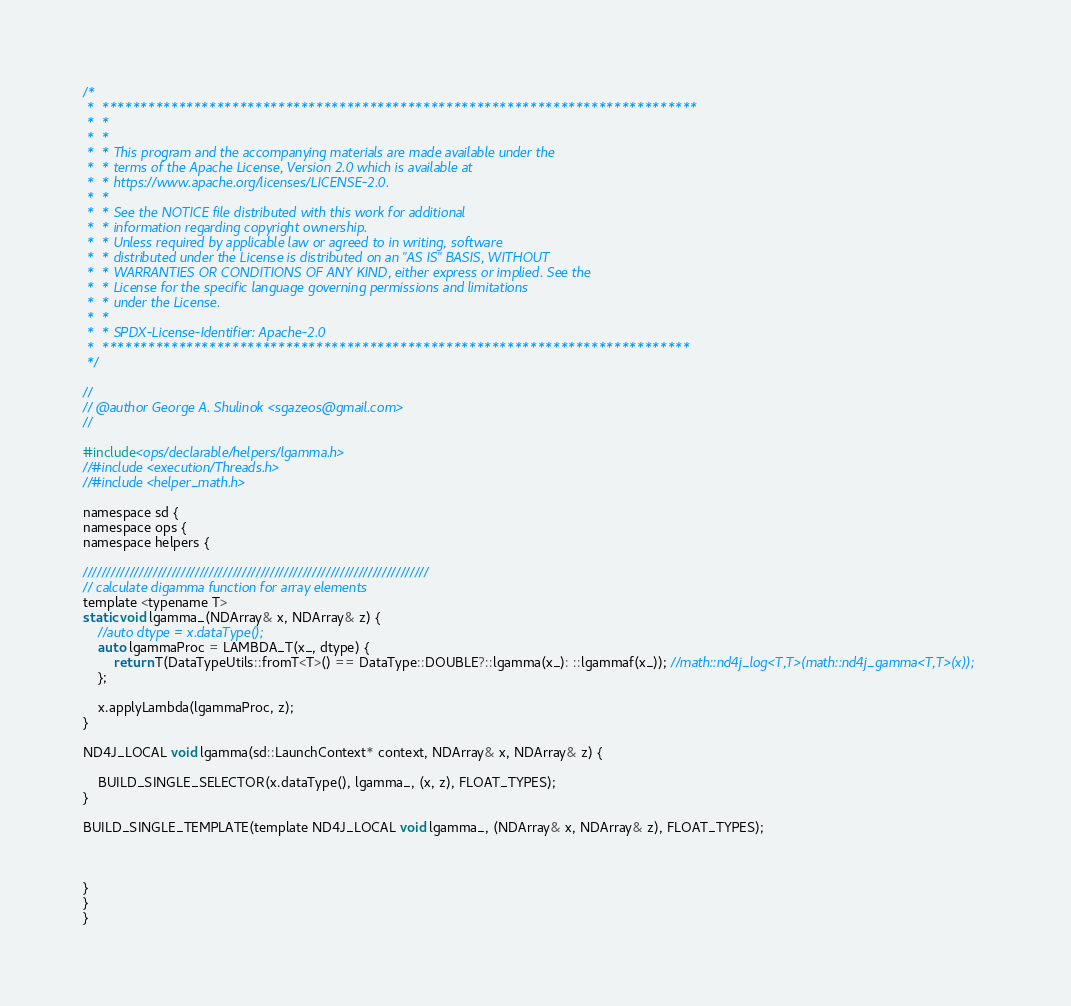Convert code to text. <code><loc_0><loc_0><loc_500><loc_500><_Cuda_>/*
 *  ******************************************************************************
 *  *
 *  *
 *  * This program and the accompanying materials are made available under the
 *  * terms of the Apache License, Version 2.0 which is available at
 *  * https://www.apache.org/licenses/LICENSE-2.0.
 *  *
 *  * See the NOTICE file distributed with this work for additional
 *  * information regarding copyright ownership.
 *  * Unless required by applicable law or agreed to in writing, software
 *  * distributed under the License is distributed on an "AS IS" BASIS, WITHOUT
 *  * WARRANTIES OR CONDITIONS OF ANY KIND, either express or implied. See the
 *  * License for the specific language governing permissions and limitations
 *  * under the License.
 *  *
 *  * SPDX-License-Identifier: Apache-2.0
 *  *****************************************************************************
 */

//
// @author George A. Shulinok <sgazeos@gmail.com>
//

#include<ops/declarable/helpers/lgamma.h>
//#include <execution/Threads.h>
//#include <helper_math.h>

namespace sd {
namespace ops {
namespace helpers {

//////////////////////////////////////////////////////////////////////////
// calculate digamma function for array elements
template <typename T>
static void lgamma_(NDArray& x, NDArray& z) {
    //auto dtype = x.dataType();
    auto lgammaProc = LAMBDA_T(x_, dtype) {
        return T(DataTypeUtils::fromT<T>() == DataType::DOUBLE?::lgamma(x_): ::lgammaf(x_)); //math::nd4j_log<T,T>(math::nd4j_gamma<T,T>(x));
    };

    x.applyLambda(lgammaProc, z);
}

ND4J_LOCAL void lgamma(sd::LaunchContext* context, NDArray& x, NDArray& z) {

	BUILD_SINGLE_SELECTOR(x.dataType(), lgamma_, (x, z), FLOAT_TYPES);
}

BUILD_SINGLE_TEMPLATE(template ND4J_LOCAL void lgamma_, (NDArray& x, NDArray& z), FLOAT_TYPES);



}
}
}

</code> 